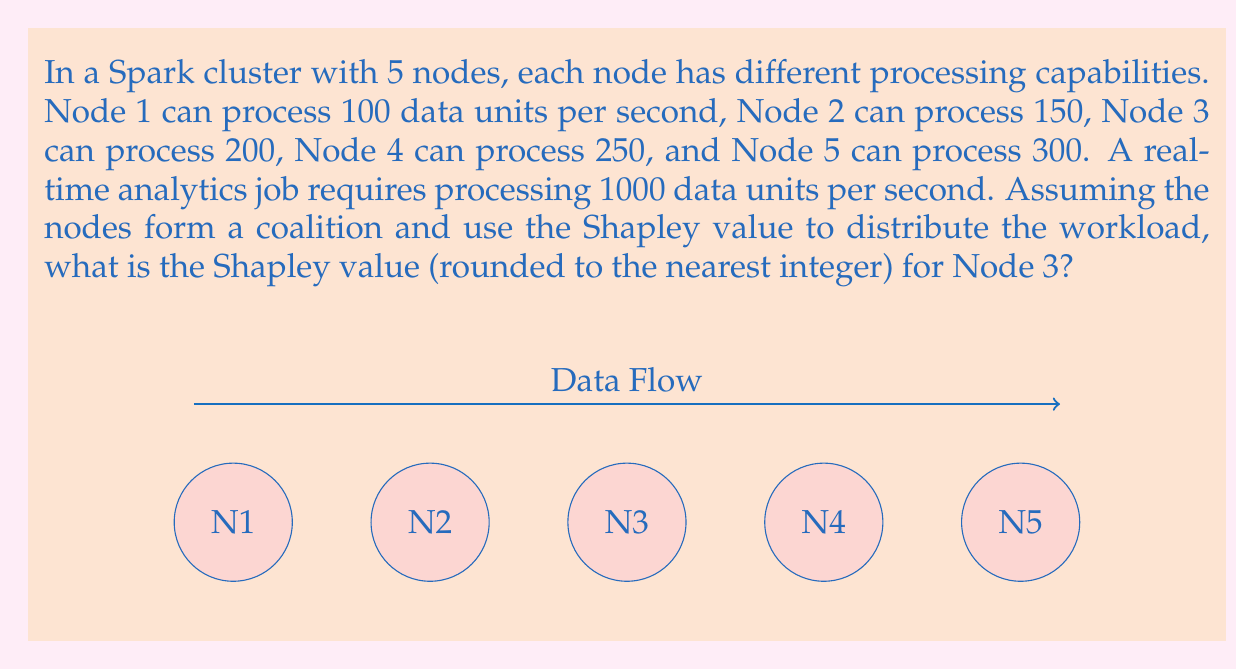Show me your answer to this math problem. To solve this problem, we need to calculate the Shapley value for Node 3. The Shapley value is a solution concept in cooperative game theory that provides a fair distribution of the total gain generated by the coalition of all players.

Step 1: Calculate the total processing capability of the cluster.
Total capability = 100 + 150 + 200 + 250 + 300 = 1000 units/second

Step 2: List all possible coalitions and their values (v).
v({}) = 0
v({1}) = 0, v({2}) = 0, v({3}) = 0, v({4}) = 0, v({5}) = 0
v({1,2}) = 0, v({1,3}) = 0, v({1,4}) = 0, v({1,5}) = 400, v({2,3}) = 0, v({2,4}) = 400, v({2,5}) = 450, v({3,4}) = 450, v({3,5}) = 500, v({4,5}) = 550
v({1,2,3}) = 450, v({1,2,4}) = 500, v({1,2,5}) = 550, v({1,3,4}) = 550, v({1,3,5}) = 600, v({1,4,5}) = 650, v({2,3,4}) = 600, v({2,3,5}) = 650, v({2,4,5}) = 700, v({3,4,5}) = 750
v({1,2,3,4}) = 700, v({1,2,3,5}) = 750, v({1,2,4,5}) = 800, v({1,3,4,5}) = 900, v({2,3,4,5}) = 900
v({1,2,3,4,5}) = 1000

Step 3: Calculate the marginal contribution of Node 3 to each coalition.

Step 4: Apply the Shapley value formula for Node 3:
$$\phi_3 = \frac{1}{5!} \sum_{S \subseteq N \setminus \{3\}} |S|!(5-|S|-1)![v(S \cup \{3\}) - v(S)]$$

Step 5: Calculate the Shapley value:
$$\phi_3 = \frac{1}{120}[24(0) + 6(0) + 6(0) + 6(50) + 6(50) + 2(450) + 2(450) + 2(500) + 2(100) + 2(100) + 1(200)]$$
$$\phi_3 = \frac{1}{120}[0 + 0 + 0 + 300 + 300 + 900 + 900 + 1000 + 200 + 200 + 200]$$
$$\phi_3 = \frac{4000}{120} = 33.33$$

Step 6: Round to the nearest integer.
Shapley value for Node 3 ≈ 33
Answer: 33 